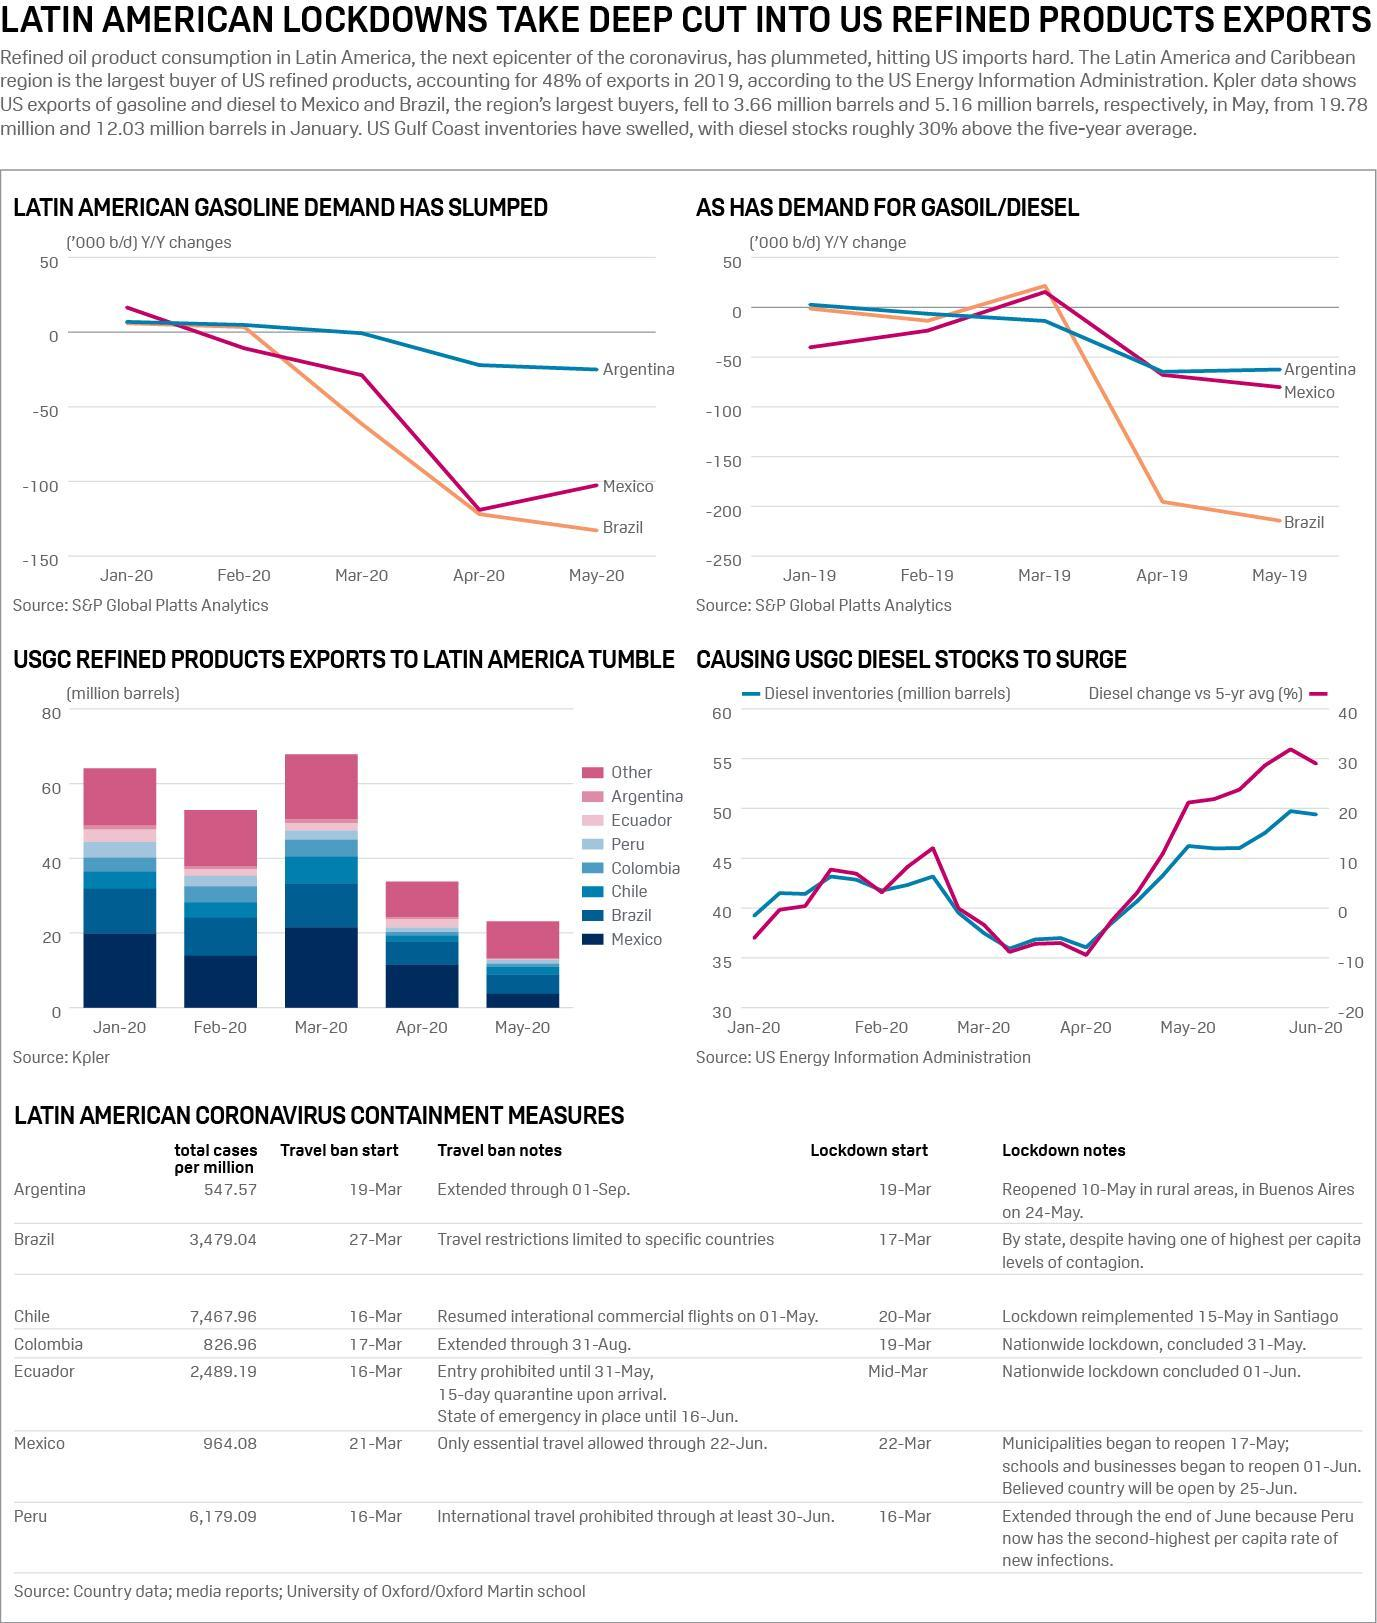When did the travel ban started in Peru?
Answer the question with a short phrase. 16-Mar When did the lockdown due to COVID-19 outbreak started in Brazil? 17-Mar What is the total number of COVID-19 cases per million population in Mexico? 964.08 What is the total number of COVID-19 cases per million population in Columbia? 826.96 When did the lockdown due to COVID-19 outbreak started in Chile? 20-Mar 